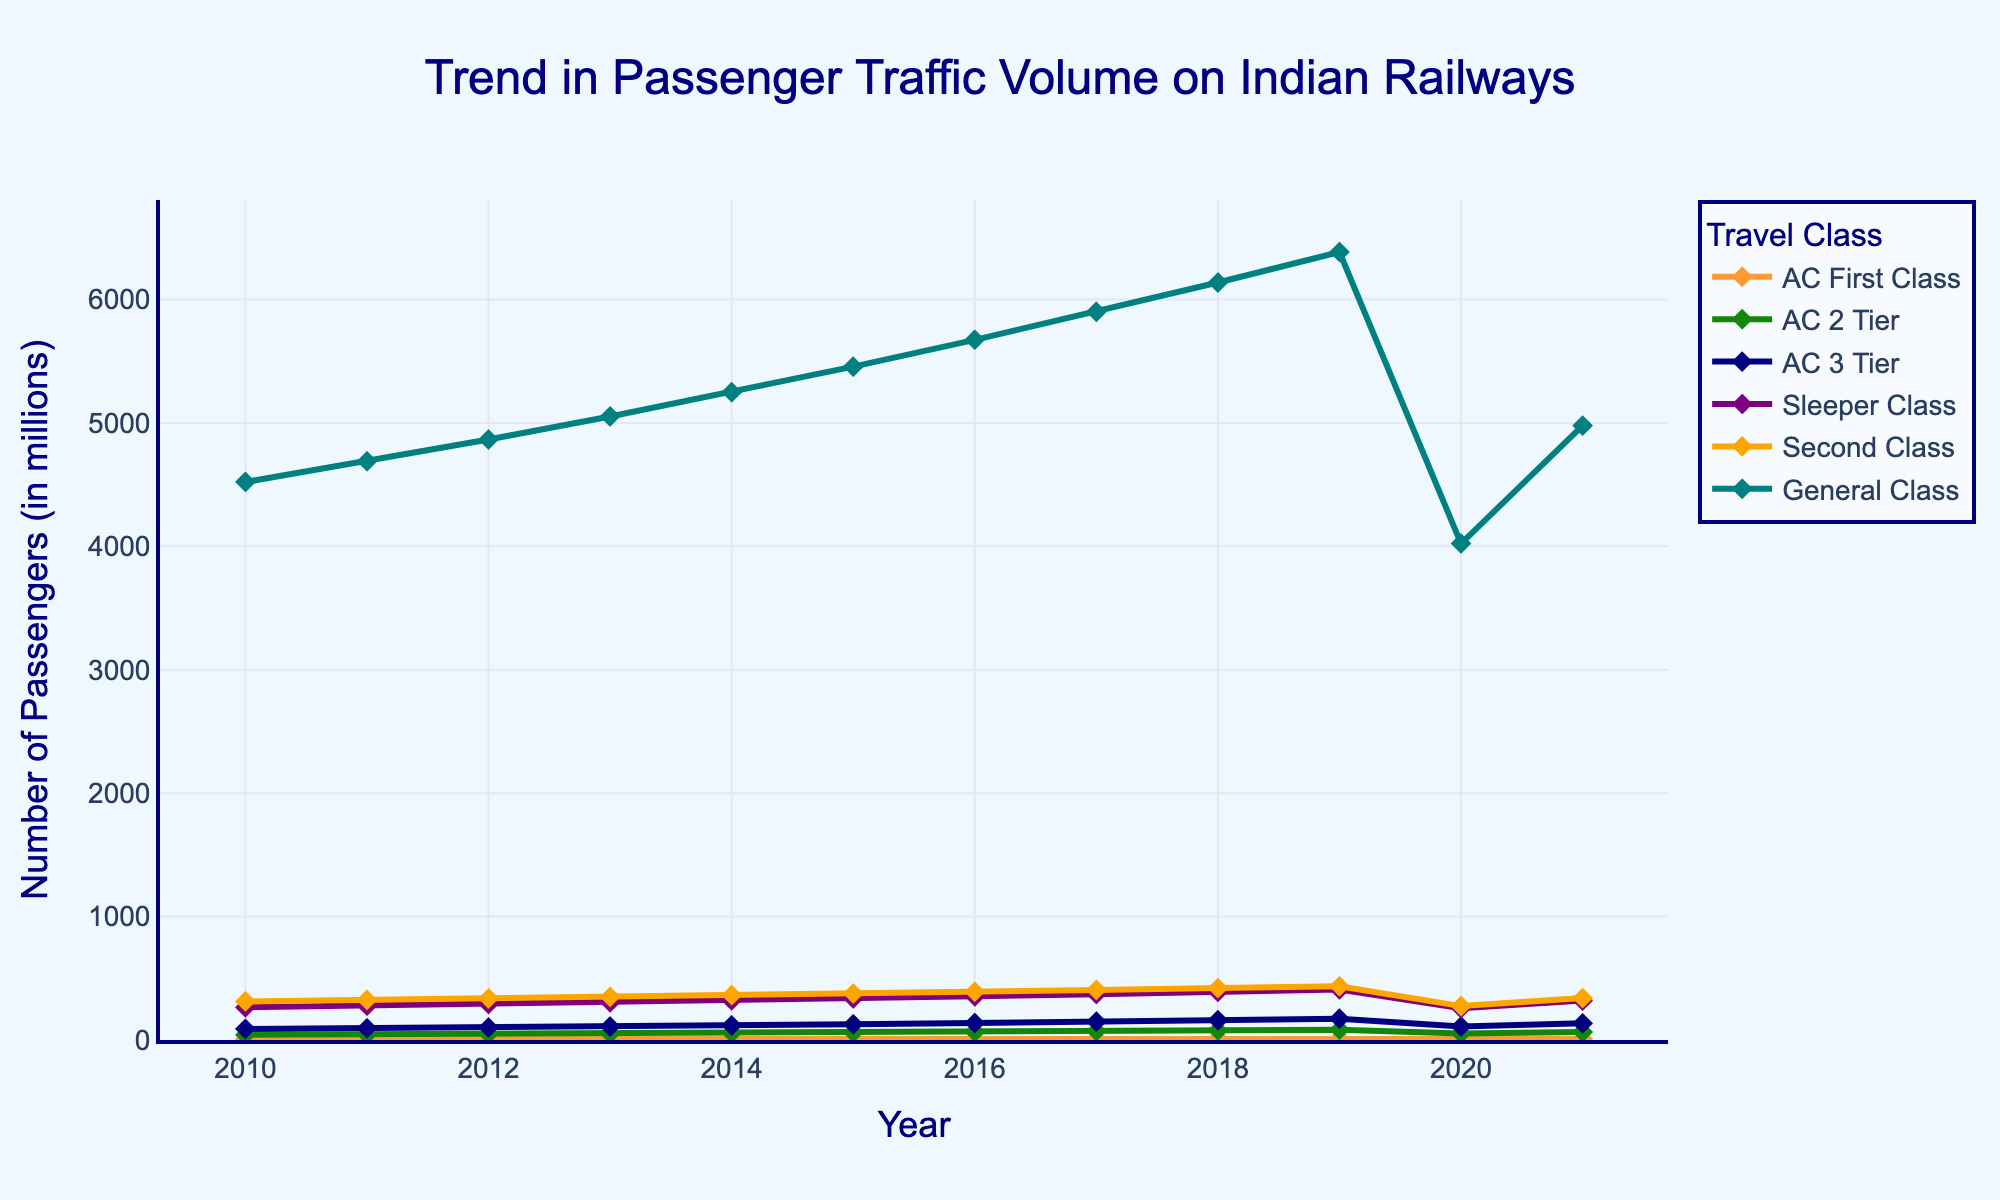Which travel class has the highest passenger volume in 2019? To find this, look at the year 2019 and compare the values for each travel class. The highest passenger volume is represented by the tallest line on the graph. For 2019, General Class has the highest volume.
Answer: General Class How does the passenger volume in Sleeper Class for 2015 compare to that in 2010? We need to compare the values for Sleeper Class in 2015 and 2010. In 2010, the volume is 265.3 million, and in 2015, it's 336.9 million. The difference is 336.9 - 265.3 = 71.6 million, indicating an increase.
Answer: Increased by 71.6 million What was the overall trend in passenger volume for AC 3 Tier from 2010 to 2021? Observe the line representing AC 3 Tier from 2010 to 2021. The volume generally increases from 89.7 million in 2010 to 173.1 million in 2019, dips in 2020, and then recovers to 134.8 million in 2021.
Answer: Increasing trend with a dip in 2020 Which year saw the lowest volume for AC First Class? Identify the lowest point on the line representing AC First Class and note the year. The lowest point is in 2020, where the volume is 7.2 million.
Answer: 2020 What is the approximate difference in passenger volume between AC 2 Tier and Second Class in 2018? Look at the values for AC 2 Tier and Second Class in 2018. AC 2 Tier is 77.1 million, and Second Class is 420.5 million. The difference is 420.5 - 77.1 = 343.4 million.
Answer: 343.4 million How did the COVID-19 pandemic impact passenger traffic in General Class? Compare the General Class volumes before (2019) and during the pandemic (2020). In 2019, it's 6384.7 million, and in 2020, it sharply reduces to 4022.4 million.
Answer: Significant decrease In which year did AC 2 Tier passenger volume first surpass 60 million? Track the line for AC 2 Tier and identify the year the volume surpasses 60 million. This happens in 2015, where the volume is 61.2 million.
Answer: 2015 What is the average annual passenger volume for Sleeper Class from 2010 to 2021? Sum the volumes for Sleeper Class across these years and then divide by the number of years (12). The sum is 2886.4 million, so the average is 2886.4 / 12 = 240.53 million (approx).
Answer: 240.53 million 